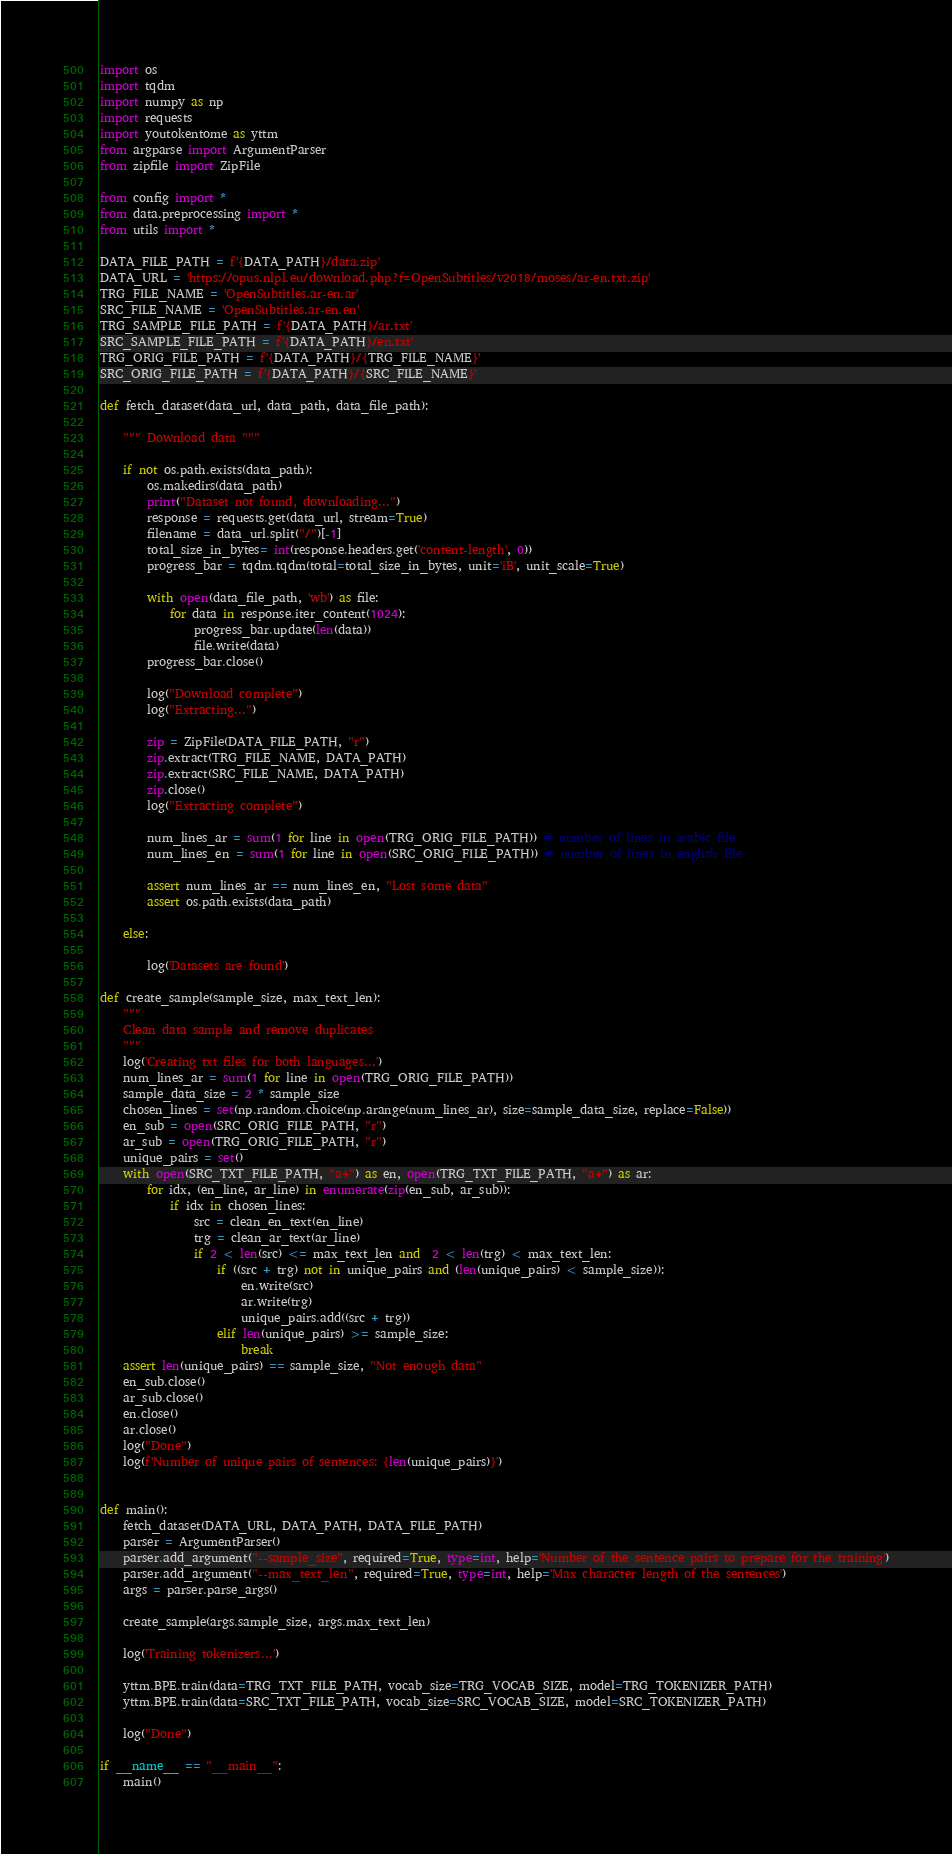Convert code to text. <code><loc_0><loc_0><loc_500><loc_500><_Python_>import os
import tqdm
import numpy as np
import requests
import youtokentome as yttm
from argparse import ArgumentParser
from zipfile import ZipFile

from config import *
from data.preprocessing import *
from utils import *

DATA_FILE_PATH = f'{DATA_PATH}/data.zip'
DATA_URL = 'https://opus.nlpl.eu/download.php?f=OpenSubtitles/v2018/moses/ar-en.txt.zip'
TRG_FILE_NAME = 'OpenSubtitles.ar-en.ar'
SRC_FILE_NAME = 'OpenSubtitles.ar-en.en'
TRG_SAMPLE_FILE_PATH = f'{DATA_PATH}/ar.txt'
SRC_SAMPLE_FILE_PATH = f'{DATA_PATH}/en.txt'
TRG_ORIG_FILE_PATH = f'{DATA_PATH}/{TRG_FILE_NAME}'
SRC_ORIG_FILE_PATH = f'{DATA_PATH}/{SRC_FILE_NAME}'

def fetch_dataset(data_url, data_path, data_file_path):
    
    """ Download data """
    
    if not os.path.exists(data_path):
        os.makedirs(data_path)
        print("Dataset not found, downloading...")
        response = requests.get(data_url, stream=True)
        filename = data_url.split("/")[-1]
        total_size_in_bytes= int(response.headers.get('content-length', 0))
        progress_bar = tqdm.tqdm(total=total_size_in_bytes, unit='iB', unit_scale=True)

        with open(data_file_path, 'wb') as file:
            for data in response.iter_content(1024):
                progress_bar.update(len(data))
                file.write(data)
        progress_bar.close()
        
        log("Download complete")
        log("Extracting...")
        
        zip = ZipFile(DATA_FILE_PATH, "r")
        zip.extract(TRG_FILE_NAME, DATA_PATH)
        zip.extract(SRC_FILE_NAME, DATA_PATH)
        zip.close()
        log("Extracting complete")
        
        num_lines_ar = sum(1 for line in open(TRG_ORIG_FILE_PATH)) # number of lines in arabic file
        num_lines_en = sum(1 for line in open(SRC_ORIG_FILE_PATH)) # number of lines in english file
        
        assert num_lines_ar == num_lines_en, "Lost some data"
        assert os.path.exists(data_path)

    else:

        log('Datasets are found')

def create_sample(sample_size, max_text_len):
    """
    Clean data sample and remove duplicates
    """
    log('Creating txt files for both languages...')
    num_lines_ar = sum(1 for line in open(TRG_ORIG_FILE_PATH)) 
    sample_data_size = 2 * sample_size 
    chosen_lines = set(np.random.choice(np.arange(num_lines_ar), size=sample_data_size, replace=False))
    en_sub = open(SRC_ORIG_FILE_PATH, "r") 
    ar_sub = open(TRG_ORIG_FILE_PATH, "r") 
    unique_pairs = set()
    with open(SRC_TXT_FILE_PATH, "a+") as en, open(TRG_TXT_FILE_PATH, "a+") as ar:
        for idx, (en_line, ar_line) in enumerate(zip(en_sub, ar_sub)):
            if idx in chosen_lines:
                src = clean_en_text(en_line)
                trg = clean_ar_text(ar_line)
                if 2 < len(src) <= max_text_len and  2 < len(trg) < max_text_len:
                    if ((src + trg) not in unique_pairs and (len(unique_pairs) < sample_size)): 
                        en.write(src)
                        ar.write(trg)
                        unique_pairs.add((src + trg))
                    elif len(unique_pairs) >= sample_size: 
                        break
    assert len(unique_pairs) == sample_size, "Not enough data"
    en_sub.close()
    ar_sub.close()
    en.close()
    ar.close()
    log("Done")
    log(f'Number of unique pairs of sentences: {len(unique_pairs)}')
        

def main():   
    fetch_dataset(DATA_URL, DATA_PATH, DATA_FILE_PATH)
    parser = ArgumentParser()
    parser.add_argument("--sample_size", required=True, type=int, help='Number of the sentence pairs to prepare for the training')
    parser.add_argument("--max_text_len", required=True, type=int, help='Max character length of the sentences')
    args = parser.parse_args()
    
    create_sample(args.sample_size, args.max_text_len)
    
    log('Training tokenizers...')
    
    yttm.BPE.train(data=TRG_TXT_FILE_PATH, vocab_size=TRG_VOCAB_SIZE, model=TRG_TOKENIZER_PATH)
    yttm.BPE.train(data=SRC_TXT_FILE_PATH, vocab_size=SRC_VOCAB_SIZE, model=SRC_TOKENIZER_PATH)
    
    log("Done")

if __name__ == "__main__":
    main()
</code> 